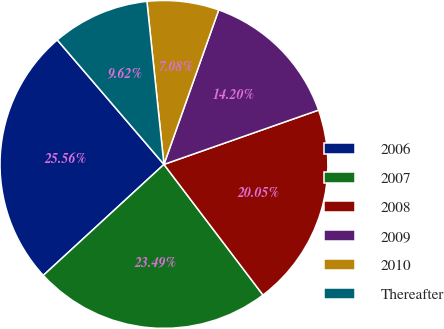Convert chart. <chart><loc_0><loc_0><loc_500><loc_500><pie_chart><fcel>2006<fcel>2007<fcel>2008<fcel>2009<fcel>2010<fcel>Thereafter<nl><fcel>25.56%<fcel>23.49%<fcel>20.05%<fcel>14.2%<fcel>7.08%<fcel>9.62%<nl></chart> 